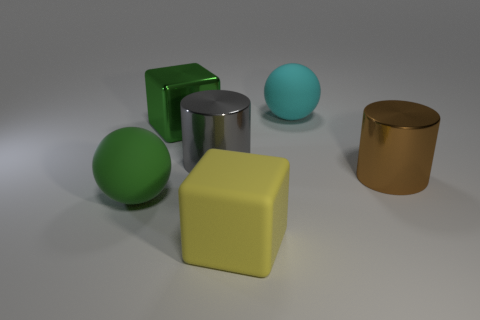How many things are either matte things that are behind the large yellow rubber thing or big spheres in front of the green shiny cube? After inspecting the image, there are two items that match your description: one large blue sphere in front of the green shiny cube, and a large green matte sphere behind the yellow rubber cube. Therefore, the total count is 2. 